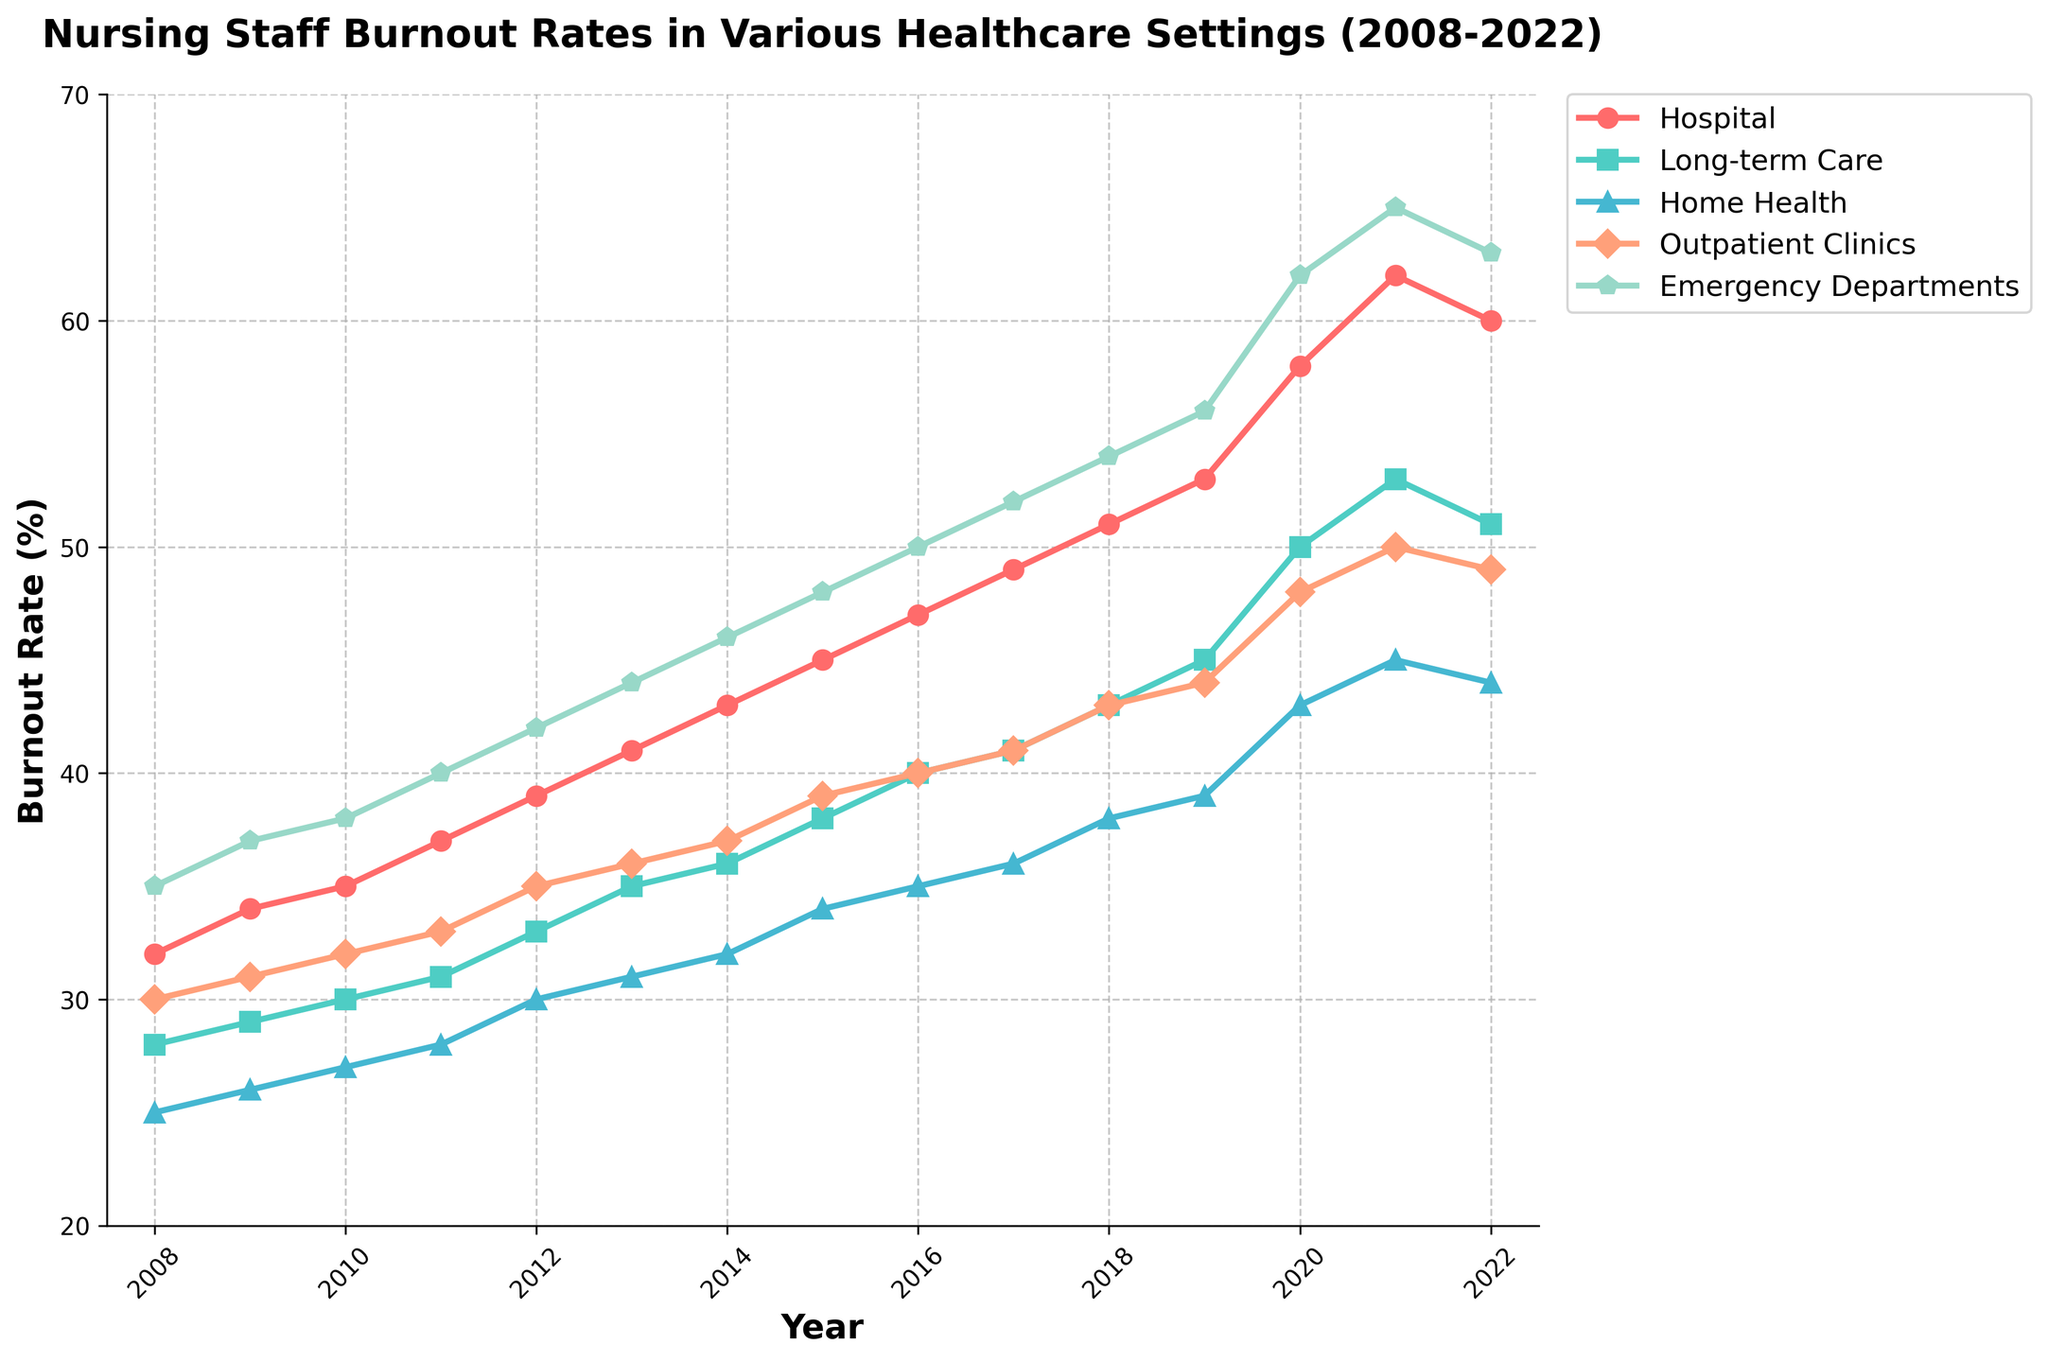What year did the burnout rate in Emergency Departments first reach 50%? The line for Emergency Departments reaches 50% in 2016.
Answer: 2016 In which healthcare setting did the burnout rate reach its peak last year among the given data? For the year 2022, Emergency Departments had the highest burnout rate at 63%.
Answer: Emergency Departments What is the average burnout rate of Hospital nurses over the first five years? The burnout rates for Hospital nurses from 2008 to 2012 are 32, 34, 35, 37, and 39. Summing them gives 177, and dividing by 5 gives 35.4.
Answer: 35.4 Which healthcare setting showed the least increase in burnout rate from 2008 to 2022? Home Health saw an increase from 25% in 2008 to 44% in 2022, the smallest increase of 19%.
Answer: Home Health During which period did Long-term Care see the highest increase in burnout rate? From 2019 to 2021, Long-term Care increased from 45% to 53%, an 8% increase.
Answer: 2019–2021 How many years did it take for the Home Health burnout rate to increase from 30% to 40%? Home Health reached 30% in 2012 and 40% in 2016, taking four years.
Answer: Four years When comparing 2014 to 2022, which setting had the highest increase in burnout rate and by how much? Emergency Departments increased from 46% in 2014 to 63% in 2022, a 17% increase.
Answer: Emergency Departments by 17% Which setting had the most consistent year-over-year increase in burnout rates? Hospitals showed a consistent increase every year from 2008 to 2021, only decreasing slightly in 2022.
Answer: Hospitals In which year did the burnout rates for Hospital and Outpatient Clinics first exceed 50%? Hospitals exceeded 50% in 2018, and Outpatient Clinics exceeded 50% in 2021.
Answer: Hospitals in 2018 and Outpatient Clinics in 2021 What is the difference in the burnout rate between Hospitals and Long-term Care settings in 2020? In 2020, Hospital burnout rate was 58%, and Long-term Care was 50%; the difference is 8%.
Answer: 8% 